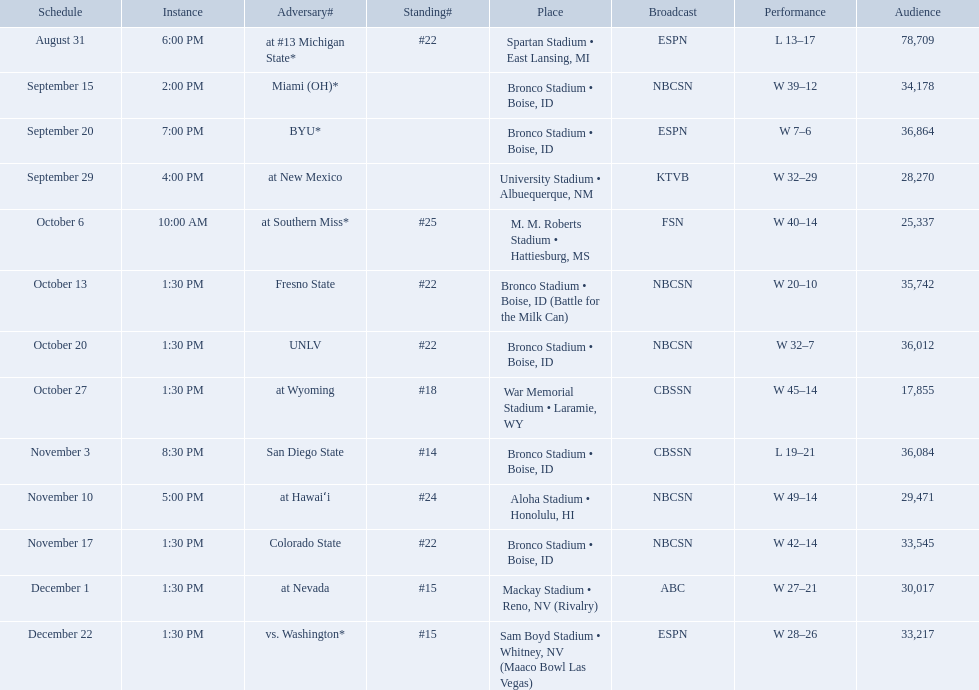What was the team's listed rankings for the season? #22, , , , #25, #22, #22, #18, #14, #24, #22, #15, #15. Which of these ranks is the best? #14. What are the opponent teams of the 2012 boise state broncos football team? At #13 michigan state*, miami (oh)*, byu*, at new mexico, at southern miss*, fresno state, unlv, at wyoming, san diego state, at hawaiʻi, colorado state, at nevada, vs. washington*. How has the highest rank of these opponents? San Diego State. 